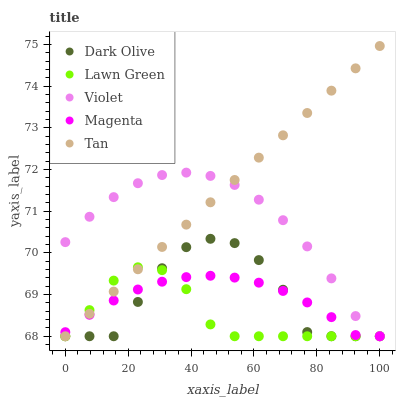Does Lawn Green have the minimum area under the curve?
Answer yes or no. Yes. Does Tan have the maximum area under the curve?
Answer yes or no. Yes. Does Magenta have the minimum area under the curve?
Answer yes or no. No. Does Magenta have the maximum area under the curve?
Answer yes or no. No. Is Tan the smoothest?
Answer yes or no. Yes. Is Dark Olive the roughest?
Answer yes or no. Yes. Is Magenta the smoothest?
Answer yes or no. No. Is Magenta the roughest?
Answer yes or no. No. Does Lawn Green have the lowest value?
Answer yes or no. Yes. Does Tan have the highest value?
Answer yes or no. Yes. Does Dark Olive have the highest value?
Answer yes or no. No. Does Violet intersect Lawn Green?
Answer yes or no. Yes. Is Violet less than Lawn Green?
Answer yes or no. No. Is Violet greater than Lawn Green?
Answer yes or no. No. 